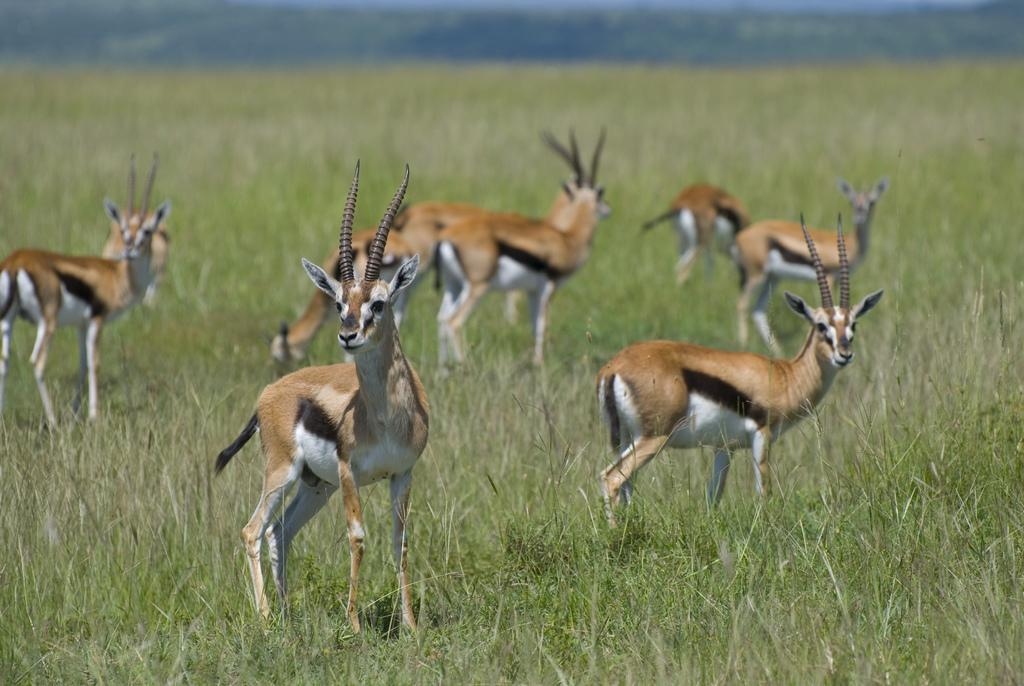What animal is present in the image? There is an antelope in the image. What is the surface on which the antelope is standing? The antelope is on a grass surface area. Can you describe the color of the antelope? The antelope is brown in color with some white parts. What can be seen in the background of the image? There is a hill visible in the background of the image. What type of honey is the antelope collecting in the image? There is no honey present in the image, and the antelope is not collecting anything. 